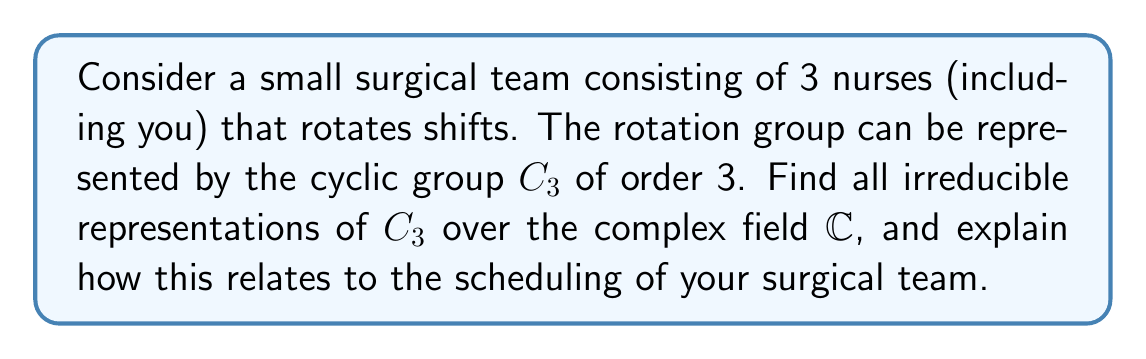Provide a solution to this math problem. 1. The cyclic group $C_3$ is generated by a single element $g$ such that $g^3 = e$ (identity).

2. For a cyclic group of order $n$, there are exactly $n$ irreducible representations over $\mathbb{C}$, each of dimension 1.

3. These representations are given by:
   $$\rho_k(g) = e^{2\pi i k/3}, \quad k = 0, 1, 2$$

4. Let's calculate each representation:
   - For $k = 0$: $\rho_0(g) = e^{2\pi i \cdot 0/3} = 1$
   - For $k = 1$: $\rho_1(g) = e^{2\pi i \cdot 1/3} = \cos(2\pi/3) + i\sin(2\pi/3) = -\frac{1}{2} + i\frac{\sqrt{3}}{2}$
   - For $k = 2$: $\rho_2(g) = e^{2\pi i \cdot 2/3} = \cos(4\pi/3) + i\sin(4\pi/3) = -\frac{1}{2} - i\frac{\sqrt{3}}{2}$

5. Relation to scheduling:
   - $\rho_0$ represents no change in schedule (identity)
   - $\rho_1$ represents a forward rotation of the schedule
   - $\rho_2$ represents a backward rotation of the schedule

These representations can be used to model the different states of your surgical team's rotation schedule, with each nurse (including yourself) moving to the next position in the rotation.
Answer: The irreducible representations of $C_3$ over $\mathbb{C}$ are:
$$\rho_0(g) = 1, \quad \rho_1(g) = -\frac{1}{2} + i\frac{\sqrt{3}}{2}, \quad \rho_2(g) = -\frac{1}{2} - i\frac{\sqrt{3}}{2}$$ 